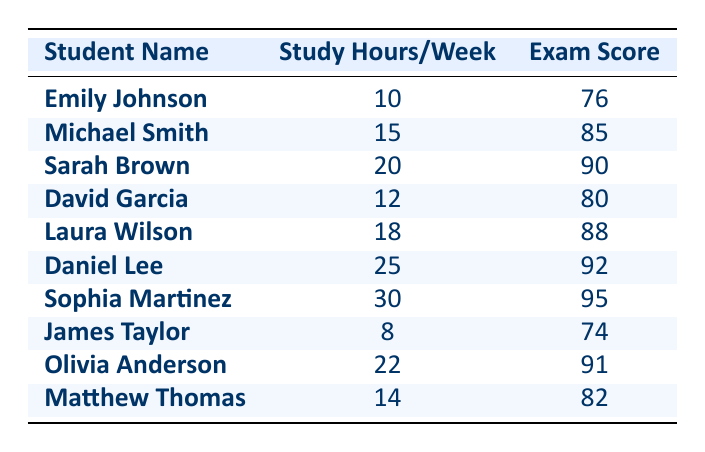What is the exam score of Sarah Brown? The table lists Sarah Brown as having an exam score of 90.
Answer: 90 How many study hours does Daniel Lee spend per week? According to the table, Daniel Lee spends 25 study hours per week.
Answer: 25 Which student has the lowest exam score, and what is that score? The lowest exam score is 74, achieved by James Taylor, as indicated in the table.
Answer: James Taylor, 74 What is the average exam score for students studying 20 hours or more per week? The students studying 20 hours or more are Sarah Brown (90), Laura Wilson (88), Daniel Lee (92), Sophia Martinez (95), and Olivia Anderson (91). Summing these scores gives 90 + 88 + 92 + 95 + 91 = 456. There are 5 students, so the average is 456/5 = 91.2.
Answer: 91.2 Is it true that all students who study 25 hours or more per week scored above 90? Yes, Daniel Lee (92) and Sophia Martinez (95) both scored above 90 while studying 25 hours or more per week, confirming the statement to be true.
Answer: Yes What is the difference in exam scores between the student with the highest score and the student with the lowest? The highest exam score is 95 (Sophia Martinez) and the lowest is 74 (James Taylor). The difference is 95 - 74 = 21.
Answer: 21 How many students study more than 15 hours per week? From the table, the students who study more than 15 hours per week are Michael Smith, Sarah Brown, Laura Wilson, Daniel Lee, Sophia Martinez, and Olivia Anderson, making a total of 6 students.
Answer: 6 What is the median exam score of all students recorded? To find the median, we organize the scores: 74, 76, 80, 82, 85, 88, 90, 91, 92, 95. There are 10 scores, so the median is the average of the 5th (85) and 6th (88) scores: (85 + 88) / 2 = 86.5.
Answer: 86.5 Which student has a study hour count and an exam score which are numerically equal? Looking through the table, Daniel Lee has 25 study hours and an exam score of 92, so no students have equal study hours and exam scores.
Answer: None 